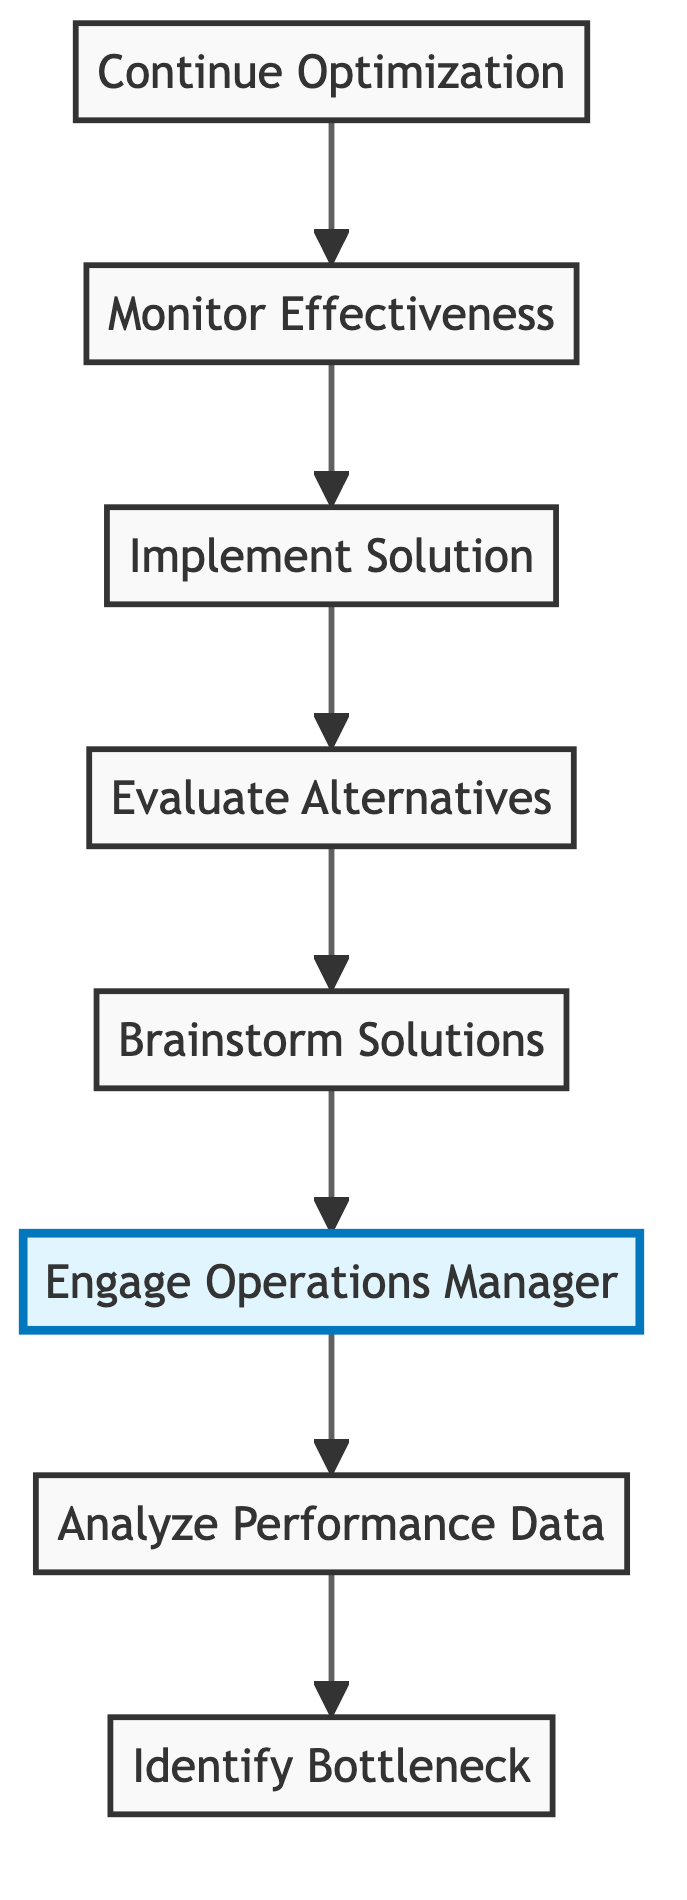What is the first step in resolving a production bottleneck? The first step in the flow is "Identify Bottleneck," which signifies the initial action to pinpoint the problem in the production process.
Answer: Identify Bottleneck What step follows "Brainstorm Solutions"? The flow indicates that "Evaluate Alternatives" comes immediately after "Brainstorm Solutions," showing the next logical action to take.
Answer: Evaluate Alternatives How many nodes are there in the diagram? Counting all the steps listed, there are a total of seven nodes in the diagram. This includes all phases of the process outlined for managing the bottleneck.
Answer: Seven Which step involves consulting with the Operations Manager? The diagram shows that the step "Engage Operations Manager" is dedicated to consulting with the Operations Manager for insights and solutions.
Answer: Engage Operations Manager What is the final action in this flow chart? The last step outlined in the flow chart is "Continue Optimization," indicating an ongoing process of adjustment to ensure efficiency.
Answer: Continue Optimization Which step directly follows "Implement Solution"? From the flow, the step that comes after "Implement Solution" is "Monitor Effectiveness," indicating the need to observe the results of the implementation.
Answer: Monitor Effectiveness How many steps are between "Identify Bottleneck" and "Continue Optimization"? There are five steps between "Identify Bottleneck" and "Continue Optimization," not counting these two endpoints. The progression is sequential as outlined in the flow.
Answer: Five What actions follow the analysis of performance data? After "Analyze Performance Data," the actions are "Engage Operations Manager" and then "Brainstorm Solutions," indicating the collaborative approach that follows the analysis.
Answer: Engage Operations Manager, Brainstorm Solutions Which step is highlighted in the flowchart? The step "Engage Operations Manager" is distinctly highlighted in the flowchart, likely indicating its importance in the process.
Answer: Engage Operations Manager 